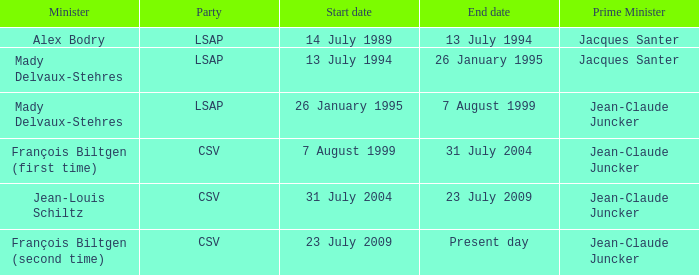Who was the minister for the CSV party with a present day end date? François Biltgen (second time). 